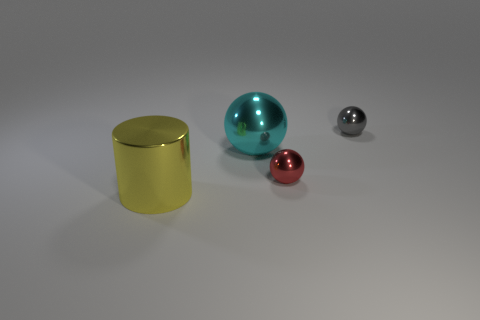Subtract all small red balls. How many balls are left? 2 Add 1 tiny gray metallic objects. How many objects exist? 5 Subtract all cyan balls. How many balls are left? 2 Subtract 0 green balls. How many objects are left? 4 Subtract all cylinders. How many objects are left? 3 Subtract all red balls. Subtract all red cylinders. How many balls are left? 2 Subtract all blue cubes. How many cyan balls are left? 1 Subtract all large balls. Subtract all small red balls. How many objects are left? 2 Add 2 large cyan metal spheres. How many large cyan metal spheres are left? 3 Add 2 large brown rubber cylinders. How many large brown rubber cylinders exist? 2 